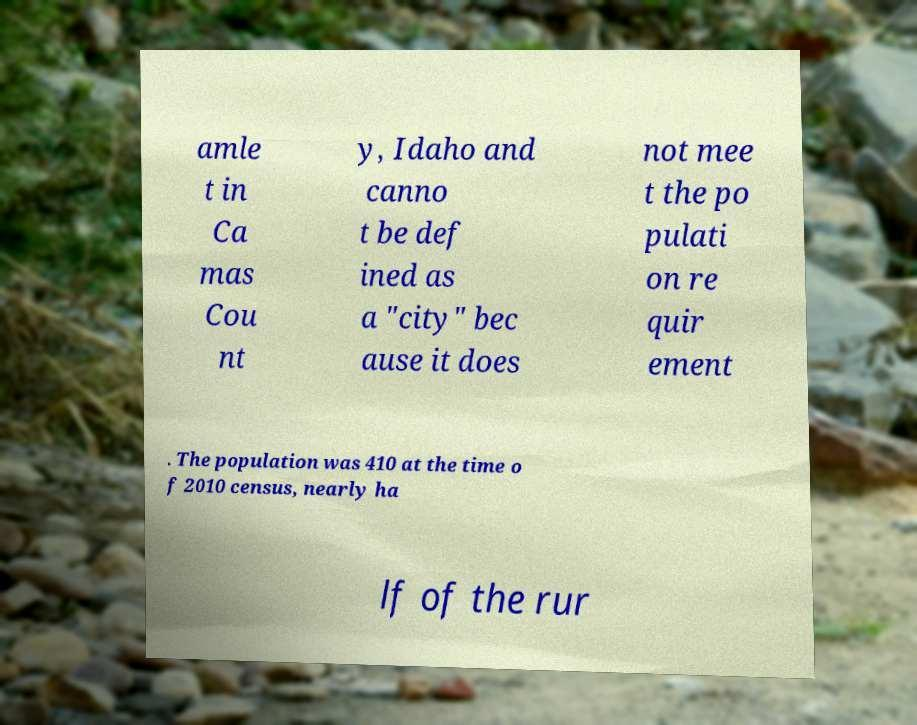Please identify and transcribe the text found in this image. amle t in Ca mas Cou nt y, Idaho and canno t be def ined as a "city" bec ause it does not mee t the po pulati on re quir ement . The population was 410 at the time o f 2010 census, nearly ha lf of the rur 